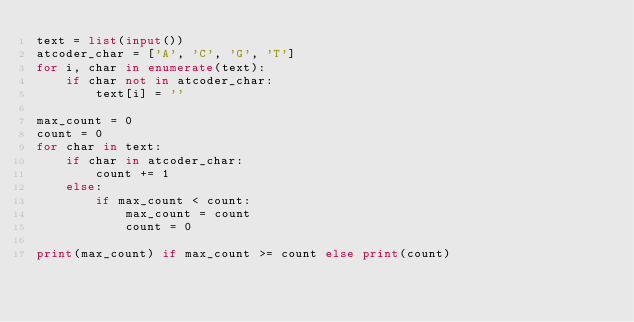Convert code to text. <code><loc_0><loc_0><loc_500><loc_500><_Python_>text = list(input())
atcoder_char = ['A', 'C', 'G', 'T']
for i, char in enumerate(text):
    if char not in atcoder_char:
        text[i] = ''

max_count = 0
count = 0
for char in text:
    if char in atcoder_char:
        count += 1
    else:
        if max_count < count:
            max_count = count
            count = 0

print(max_count) if max_count >= count else print(count)</code> 